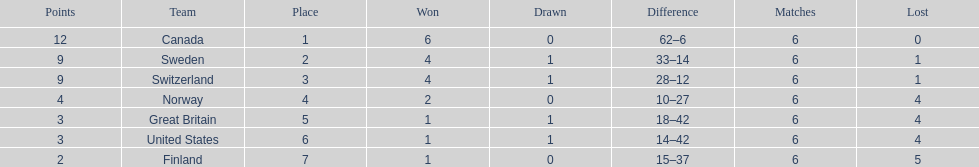Which team won more matches, finland or norway? Norway. 